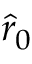Convert formula to latex. <formula><loc_0><loc_0><loc_500><loc_500>\hat { r } _ { 0 }</formula> 